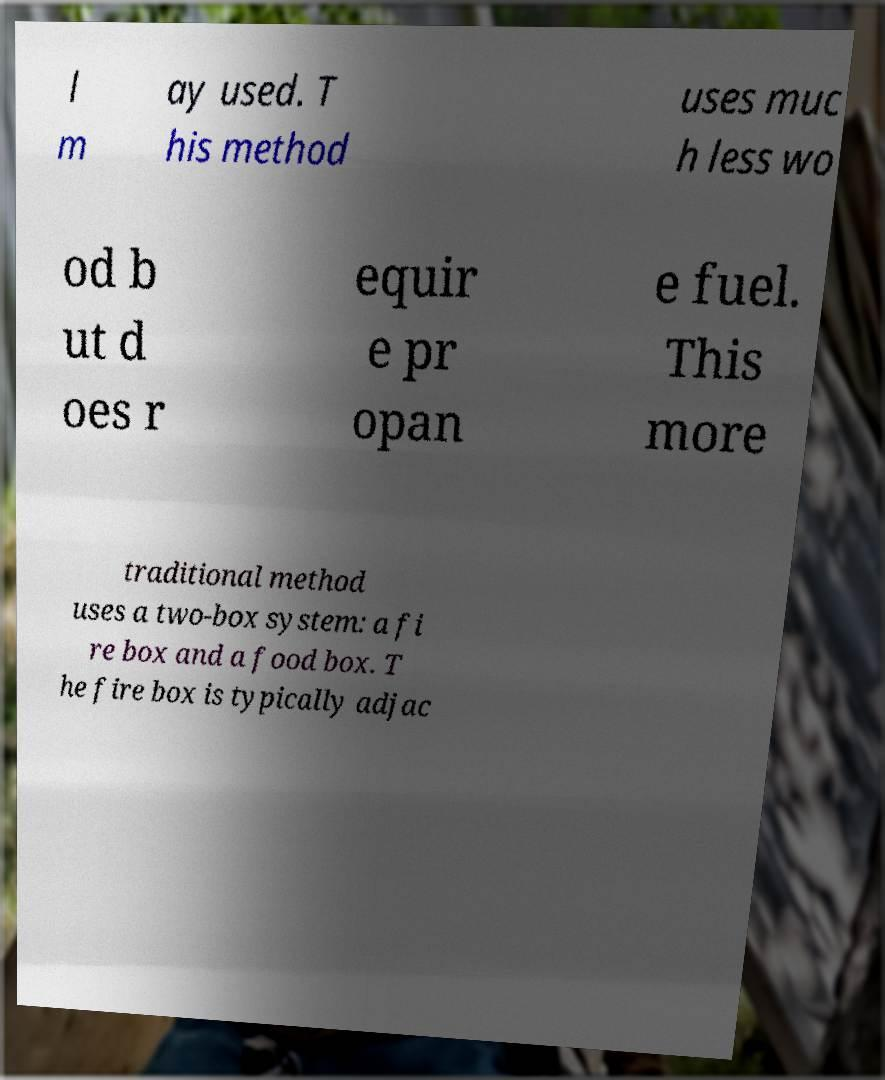For documentation purposes, I need the text within this image transcribed. Could you provide that? l m ay used. T his method uses muc h less wo od b ut d oes r equir e pr opan e fuel. This more traditional method uses a two-box system: a fi re box and a food box. T he fire box is typically adjac 